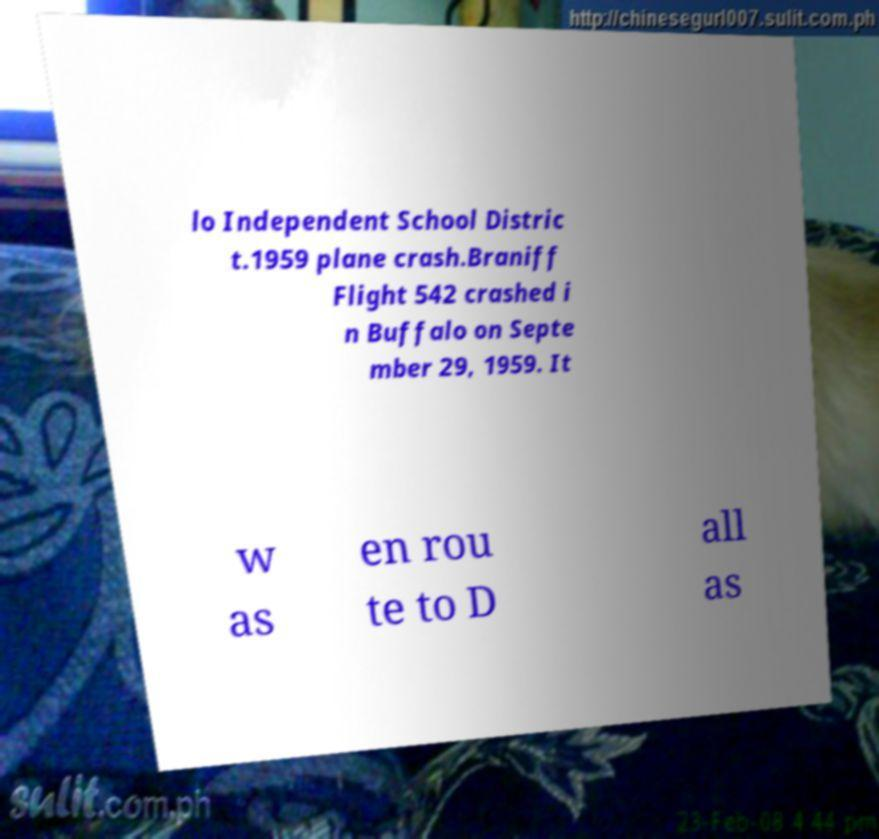I need the written content from this picture converted into text. Can you do that? lo Independent School Distric t.1959 plane crash.Braniff Flight 542 crashed i n Buffalo on Septe mber 29, 1959. It w as en rou te to D all as 